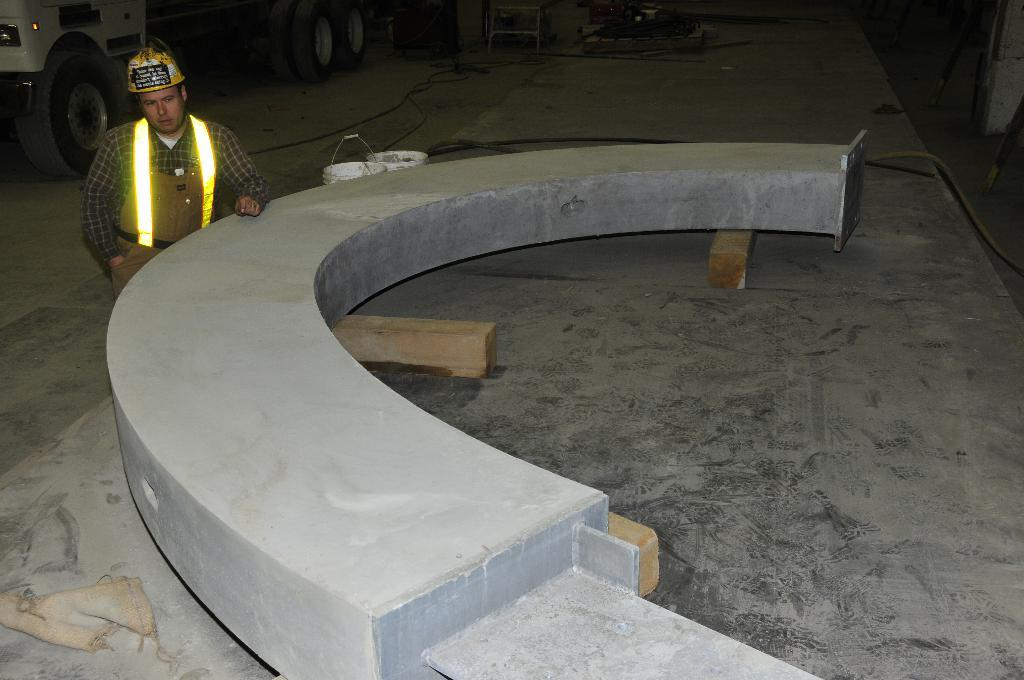What type of structure is in the picture? There is an arch construction in the picture. Can you describe the person in the image? The person is wearing a helmet and is visible on the left side of the image. What else can be seen in the image? There is a vehicle and buckets present in the image. What type of insurance does the person in the image have for their helmet? There is no information about insurance in the image, and the person's helmet is not the focus of the image. What type of drink is the person holding in the image? There is no drink visible in the image; the person is wearing a helmet and standing near an arch construction. 